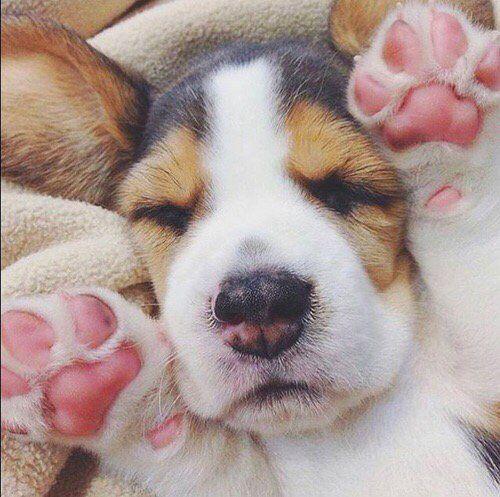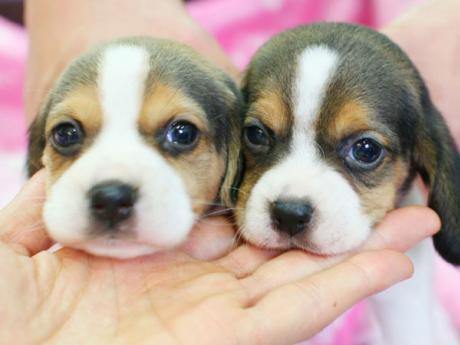The first image is the image on the left, the second image is the image on the right. Evaluate the accuracy of this statement regarding the images: "there is a beagle puppy lying belly down in the image to the left". Is it true? Answer yes or no. No. The first image is the image on the left, the second image is the image on the right. Analyze the images presented: Is the assertion "The image on the right shows at least one beagle puppy held by a human hand." valid? Answer yes or no. Yes. 